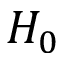Convert formula to latex. <formula><loc_0><loc_0><loc_500><loc_500>H _ { 0 }</formula> 